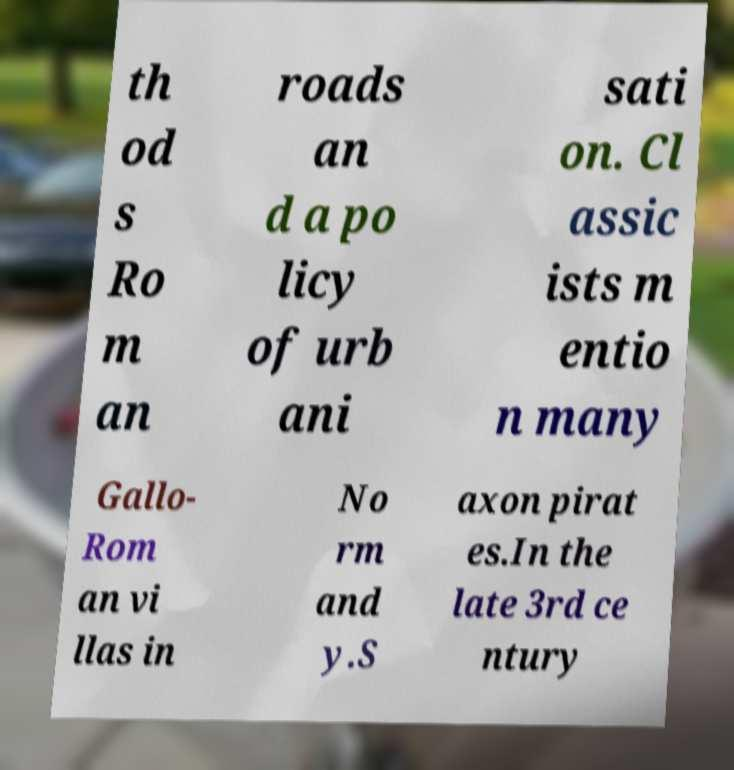Can you read and provide the text displayed in the image?This photo seems to have some interesting text. Can you extract and type it out for me? th od s Ro m an roads an d a po licy of urb ani sati on. Cl assic ists m entio n many Gallo- Rom an vi llas in No rm and y.S axon pirat es.In the late 3rd ce ntury 